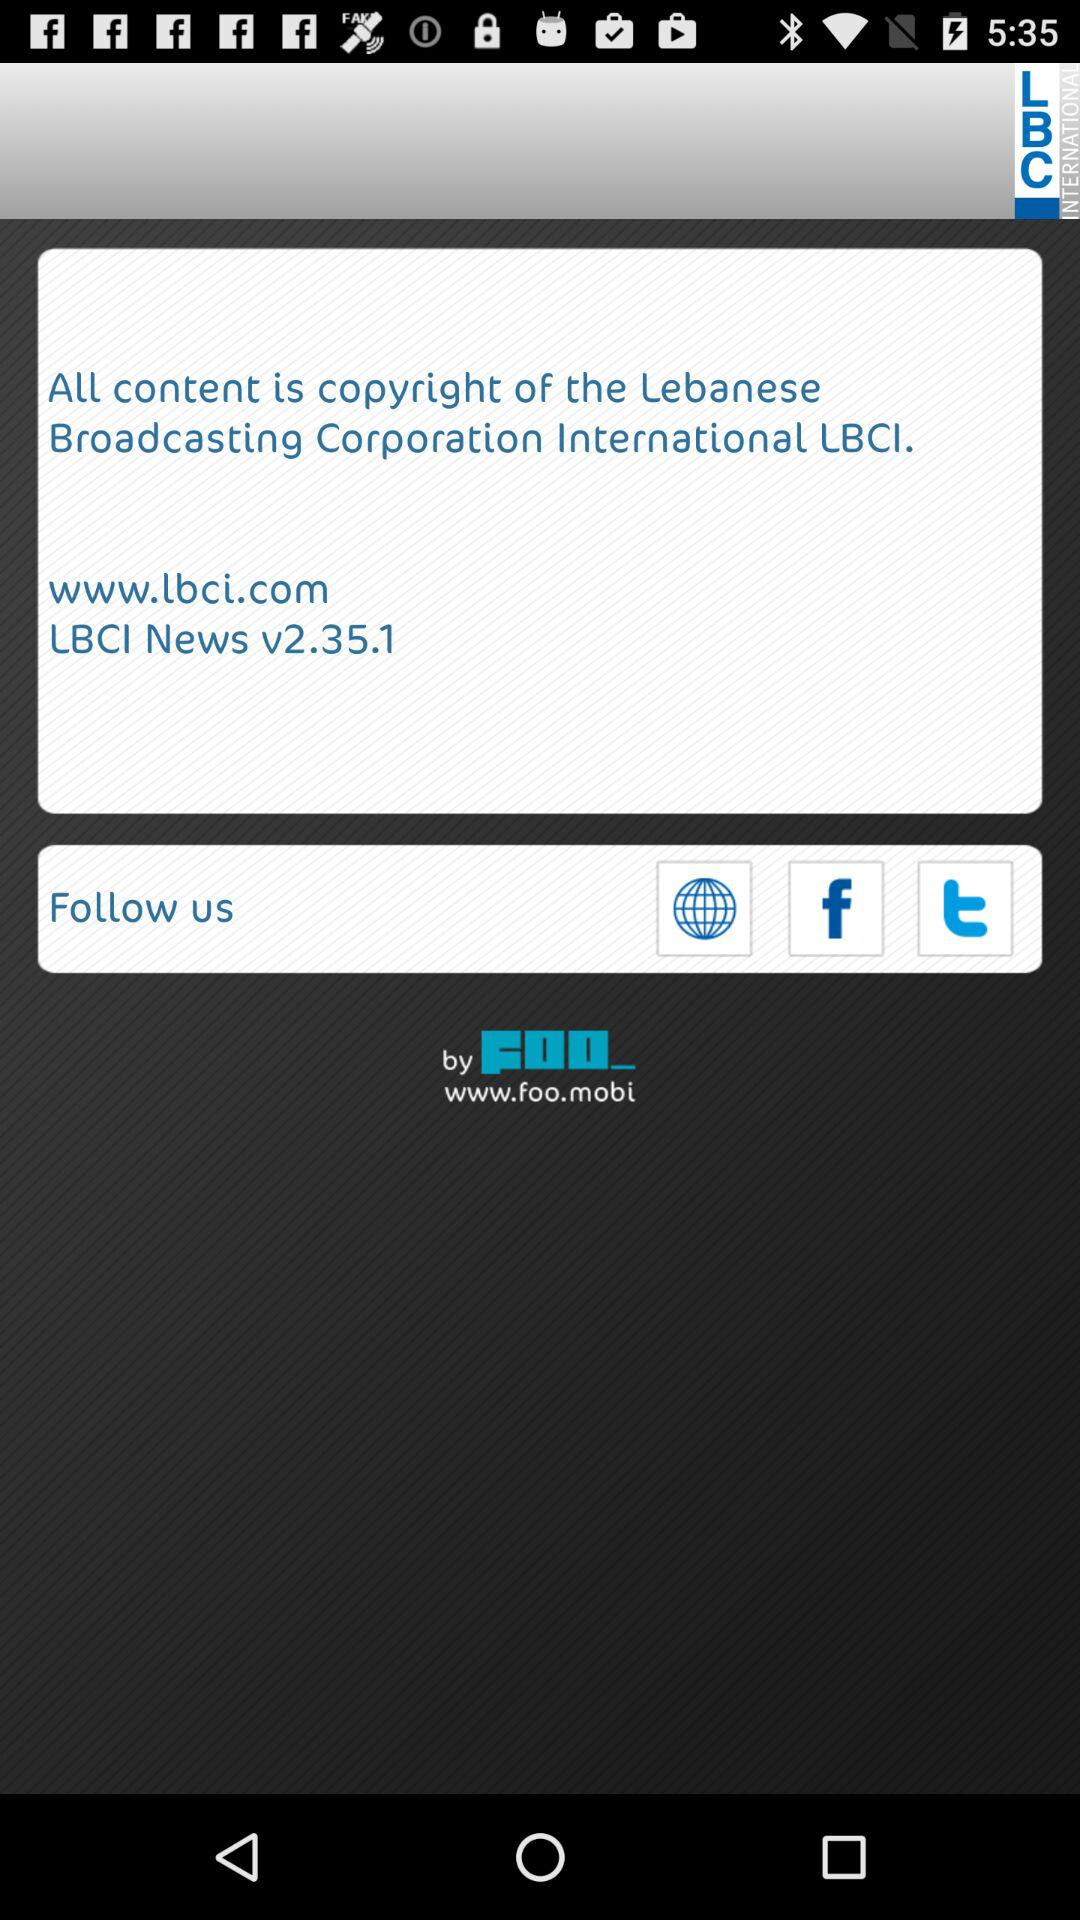What is the version? The version is v2.35.1. 